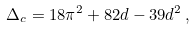Convert formula to latex. <formula><loc_0><loc_0><loc_500><loc_500>\Delta _ { c } = 1 8 \pi ^ { 2 } + 8 2 d - 3 9 d ^ { 2 } \, ,</formula> 